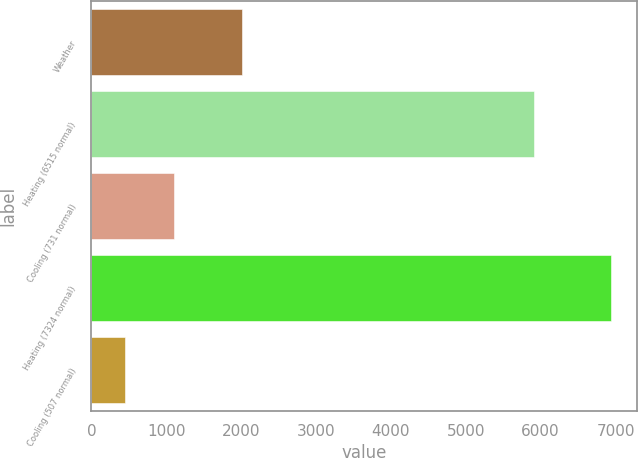Convert chart to OTSL. <chart><loc_0><loc_0><loc_500><loc_500><bar_chart><fcel>Weather<fcel>Heating (6515 normal)<fcel>Cooling (731 normal)<fcel>Heating (7324 normal)<fcel>Cooling (507 normal)<nl><fcel>2017<fcel>5908<fcel>1099.2<fcel>6942<fcel>450<nl></chart> 